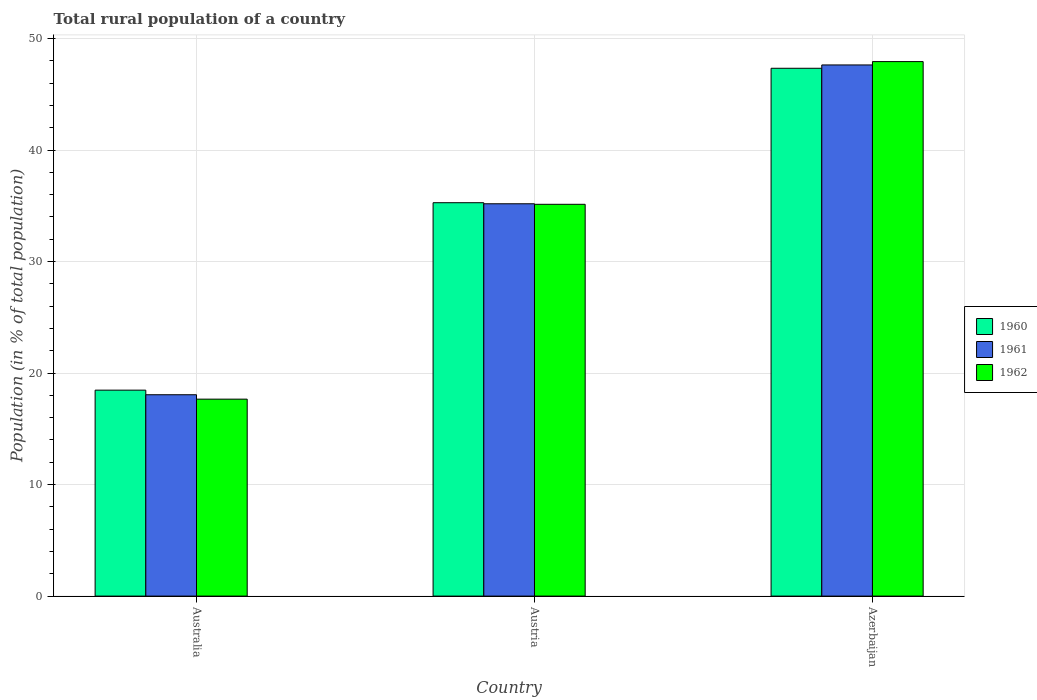Are the number of bars on each tick of the X-axis equal?
Provide a short and direct response. Yes. How many bars are there on the 2nd tick from the right?
Your answer should be compact. 3. What is the label of the 2nd group of bars from the left?
Provide a succinct answer. Austria. What is the rural population in 1961 in Australia?
Keep it short and to the point. 18.06. Across all countries, what is the maximum rural population in 1961?
Your answer should be very brief. 47.64. Across all countries, what is the minimum rural population in 1961?
Your answer should be very brief. 18.06. In which country was the rural population in 1962 maximum?
Offer a terse response. Azerbaijan. What is the total rural population in 1960 in the graph?
Provide a short and direct response. 101.09. What is the difference between the rural population in 1962 in Austria and that in Azerbaijan?
Offer a very short reply. -12.8. What is the difference between the rural population in 1962 in Azerbaijan and the rural population in 1961 in Austria?
Provide a short and direct response. 12.75. What is the average rural population in 1962 per country?
Offer a terse response. 33.58. What is the difference between the rural population of/in 1962 and rural population of/in 1961 in Azerbaijan?
Make the answer very short. 0.3. In how many countries, is the rural population in 1960 greater than 48 %?
Ensure brevity in your answer.  0. What is the ratio of the rural population in 1960 in Australia to that in Austria?
Keep it short and to the point. 0.52. Is the rural population in 1961 in Australia less than that in Azerbaijan?
Your answer should be compact. Yes. Is the difference between the rural population in 1962 in Austria and Azerbaijan greater than the difference between the rural population in 1961 in Austria and Azerbaijan?
Ensure brevity in your answer.  No. What is the difference between the highest and the second highest rural population in 1960?
Ensure brevity in your answer.  -16.81. What is the difference between the highest and the lowest rural population in 1960?
Your answer should be very brief. 28.87. In how many countries, is the rural population in 1960 greater than the average rural population in 1960 taken over all countries?
Give a very brief answer. 2. What does the 2nd bar from the left in Austria represents?
Your answer should be compact. 1961. Is it the case that in every country, the sum of the rural population in 1960 and rural population in 1962 is greater than the rural population in 1961?
Keep it short and to the point. Yes. How many bars are there?
Your response must be concise. 9. What is the difference between two consecutive major ticks on the Y-axis?
Make the answer very short. 10. Are the values on the major ticks of Y-axis written in scientific E-notation?
Your response must be concise. No. What is the title of the graph?
Give a very brief answer. Total rural population of a country. What is the label or title of the X-axis?
Provide a succinct answer. Country. What is the label or title of the Y-axis?
Ensure brevity in your answer.  Population (in % of total population). What is the Population (in % of total population) of 1960 in Australia?
Offer a terse response. 18.47. What is the Population (in % of total population) in 1961 in Australia?
Your answer should be compact. 18.06. What is the Population (in % of total population) in 1962 in Australia?
Make the answer very short. 17.66. What is the Population (in % of total population) in 1960 in Austria?
Your answer should be compact. 35.28. What is the Population (in % of total population) in 1961 in Austria?
Keep it short and to the point. 35.19. What is the Population (in % of total population) in 1962 in Austria?
Offer a terse response. 35.14. What is the Population (in % of total population) in 1960 in Azerbaijan?
Your response must be concise. 47.34. What is the Population (in % of total population) of 1961 in Azerbaijan?
Provide a short and direct response. 47.64. What is the Population (in % of total population) of 1962 in Azerbaijan?
Keep it short and to the point. 47.94. Across all countries, what is the maximum Population (in % of total population) in 1960?
Offer a very short reply. 47.34. Across all countries, what is the maximum Population (in % of total population) in 1961?
Make the answer very short. 47.64. Across all countries, what is the maximum Population (in % of total population) of 1962?
Provide a succinct answer. 47.94. Across all countries, what is the minimum Population (in % of total population) in 1960?
Ensure brevity in your answer.  18.47. Across all countries, what is the minimum Population (in % of total population) of 1961?
Your answer should be compact. 18.06. Across all countries, what is the minimum Population (in % of total population) in 1962?
Give a very brief answer. 17.66. What is the total Population (in % of total population) in 1960 in the graph?
Provide a succinct answer. 101.09. What is the total Population (in % of total population) in 1961 in the graph?
Provide a short and direct response. 100.88. What is the total Population (in % of total population) in 1962 in the graph?
Provide a short and direct response. 100.74. What is the difference between the Population (in % of total population) of 1960 in Australia and that in Austria?
Give a very brief answer. -16.81. What is the difference between the Population (in % of total population) of 1961 in Australia and that in Austria?
Provide a succinct answer. -17.13. What is the difference between the Population (in % of total population) in 1962 in Australia and that in Austria?
Keep it short and to the point. -17.47. What is the difference between the Population (in % of total population) of 1960 in Australia and that in Azerbaijan?
Give a very brief answer. -28.87. What is the difference between the Population (in % of total population) in 1961 in Australia and that in Azerbaijan?
Keep it short and to the point. -29.58. What is the difference between the Population (in % of total population) of 1962 in Australia and that in Azerbaijan?
Keep it short and to the point. -30.27. What is the difference between the Population (in % of total population) of 1960 in Austria and that in Azerbaijan?
Keep it short and to the point. -12.06. What is the difference between the Population (in % of total population) of 1961 in Austria and that in Azerbaijan?
Provide a succinct answer. -12.45. What is the difference between the Population (in % of total population) in 1962 in Austria and that in Azerbaijan?
Offer a very short reply. -12.8. What is the difference between the Population (in % of total population) of 1960 in Australia and the Population (in % of total population) of 1961 in Austria?
Provide a succinct answer. -16.71. What is the difference between the Population (in % of total population) of 1960 in Australia and the Population (in % of total population) of 1962 in Austria?
Your answer should be very brief. -16.67. What is the difference between the Population (in % of total population) in 1961 in Australia and the Population (in % of total population) in 1962 in Austria?
Your answer should be compact. -17.08. What is the difference between the Population (in % of total population) in 1960 in Australia and the Population (in % of total population) in 1961 in Azerbaijan?
Offer a terse response. -29.16. What is the difference between the Population (in % of total population) in 1960 in Australia and the Population (in % of total population) in 1962 in Azerbaijan?
Make the answer very short. -29.46. What is the difference between the Population (in % of total population) of 1961 in Australia and the Population (in % of total population) of 1962 in Azerbaijan?
Your answer should be compact. -29.88. What is the difference between the Population (in % of total population) in 1960 in Austria and the Population (in % of total population) in 1961 in Azerbaijan?
Keep it short and to the point. -12.36. What is the difference between the Population (in % of total population) of 1960 in Austria and the Population (in % of total population) of 1962 in Azerbaijan?
Your answer should be very brief. -12.66. What is the difference between the Population (in % of total population) in 1961 in Austria and the Population (in % of total population) in 1962 in Azerbaijan?
Offer a very short reply. -12.75. What is the average Population (in % of total population) in 1960 per country?
Provide a short and direct response. 33.7. What is the average Population (in % of total population) in 1961 per country?
Ensure brevity in your answer.  33.63. What is the average Population (in % of total population) of 1962 per country?
Offer a very short reply. 33.58. What is the difference between the Population (in % of total population) of 1960 and Population (in % of total population) of 1961 in Australia?
Keep it short and to the point. 0.41. What is the difference between the Population (in % of total population) of 1960 and Population (in % of total population) of 1962 in Australia?
Offer a very short reply. 0.81. What is the difference between the Population (in % of total population) in 1961 and Population (in % of total population) in 1962 in Australia?
Give a very brief answer. 0.4. What is the difference between the Population (in % of total population) in 1960 and Population (in % of total population) in 1961 in Austria?
Your answer should be compact. 0.09. What is the difference between the Population (in % of total population) of 1960 and Population (in % of total population) of 1962 in Austria?
Ensure brevity in your answer.  0.14. What is the difference between the Population (in % of total population) in 1961 and Population (in % of total population) in 1962 in Austria?
Give a very brief answer. 0.05. What is the difference between the Population (in % of total population) in 1960 and Population (in % of total population) in 1961 in Azerbaijan?
Provide a short and direct response. -0.3. What is the difference between the Population (in % of total population) of 1960 and Population (in % of total population) of 1962 in Azerbaijan?
Your response must be concise. -0.6. What is the ratio of the Population (in % of total population) of 1960 in Australia to that in Austria?
Provide a succinct answer. 0.52. What is the ratio of the Population (in % of total population) of 1961 in Australia to that in Austria?
Make the answer very short. 0.51. What is the ratio of the Population (in % of total population) in 1962 in Australia to that in Austria?
Provide a succinct answer. 0.5. What is the ratio of the Population (in % of total population) in 1960 in Australia to that in Azerbaijan?
Your answer should be compact. 0.39. What is the ratio of the Population (in % of total population) of 1961 in Australia to that in Azerbaijan?
Your answer should be compact. 0.38. What is the ratio of the Population (in % of total population) of 1962 in Australia to that in Azerbaijan?
Make the answer very short. 0.37. What is the ratio of the Population (in % of total population) in 1960 in Austria to that in Azerbaijan?
Provide a short and direct response. 0.75. What is the ratio of the Population (in % of total population) in 1961 in Austria to that in Azerbaijan?
Keep it short and to the point. 0.74. What is the ratio of the Population (in % of total population) of 1962 in Austria to that in Azerbaijan?
Offer a terse response. 0.73. What is the difference between the highest and the second highest Population (in % of total population) in 1960?
Provide a succinct answer. 12.06. What is the difference between the highest and the second highest Population (in % of total population) of 1961?
Your response must be concise. 12.45. What is the difference between the highest and the second highest Population (in % of total population) of 1962?
Make the answer very short. 12.8. What is the difference between the highest and the lowest Population (in % of total population) of 1960?
Keep it short and to the point. 28.87. What is the difference between the highest and the lowest Population (in % of total population) in 1961?
Your answer should be compact. 29.58. What is the difference between the highest and the lowest Population (in % of total population) in 1962?
Keep it short and to the point. 30.27. 